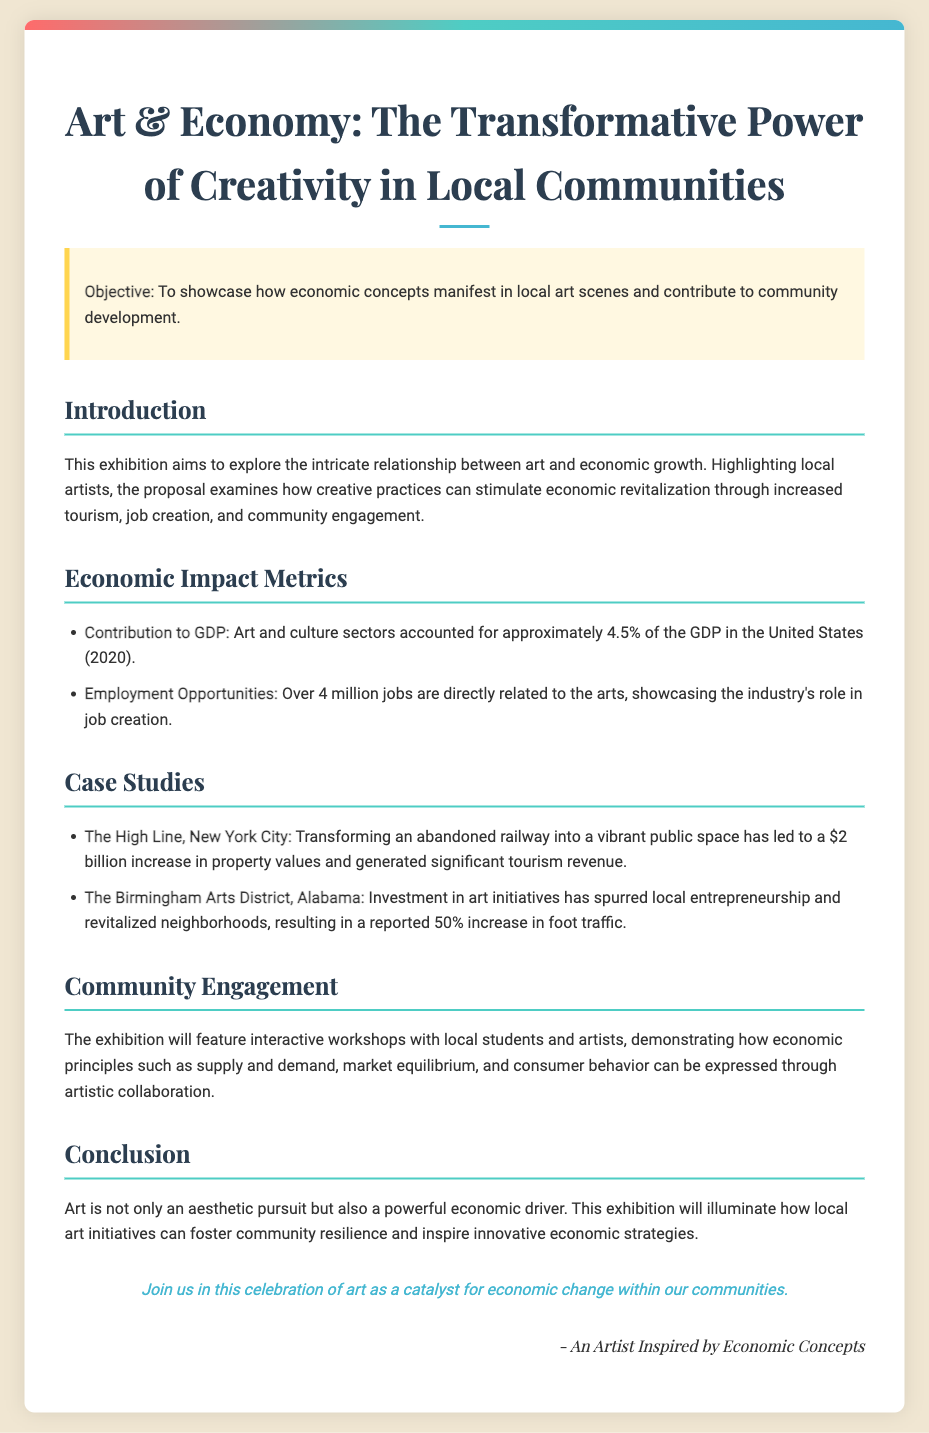what is the title of the exhibition proposal? The title of the exhibition proposal is the main heading presented at the top of the document.
Answer: Art & Economy: The Transformative Power of Creativity in Local Communities what percentage of GDP do art and culture sectors account for? The document specifies a percentage of GDP attributed to the art and culture sectors based on the data provided.
Answer: 4.5% how many jobs are directly related to the arts? The document provides a specific number of jobs related to the arts sector.
Answer: Over 4 million which city is mentioned in the case study involving a $2 billion increase in property values? The case study includes a city that transformed a railway into a public space leading to significant financial impact.
Answer: New York City what economic concept is highlighted in the community engagement workshops? The document mentions a specific economic principle that will be expressed through artistic collaboration.
Answer: Supply and demand what is the reported increase in foot traffic in the Birmingham Arts District? The document reveals a percentage increase in foot traffic due to art initiatives in a specific location.
Answer: 50% who is the author of the proposal? The document includes a signature section identifying the individual behind the exhibition proposal.
Answer: An Artist Inspired by Economic Concepts what is the objective of the exhibition? The objective provides insight into the primary goal of the exhibition as stated in the document.
Answer: To showcase how economic concepts manifest in local art scenes and contribute to community development 